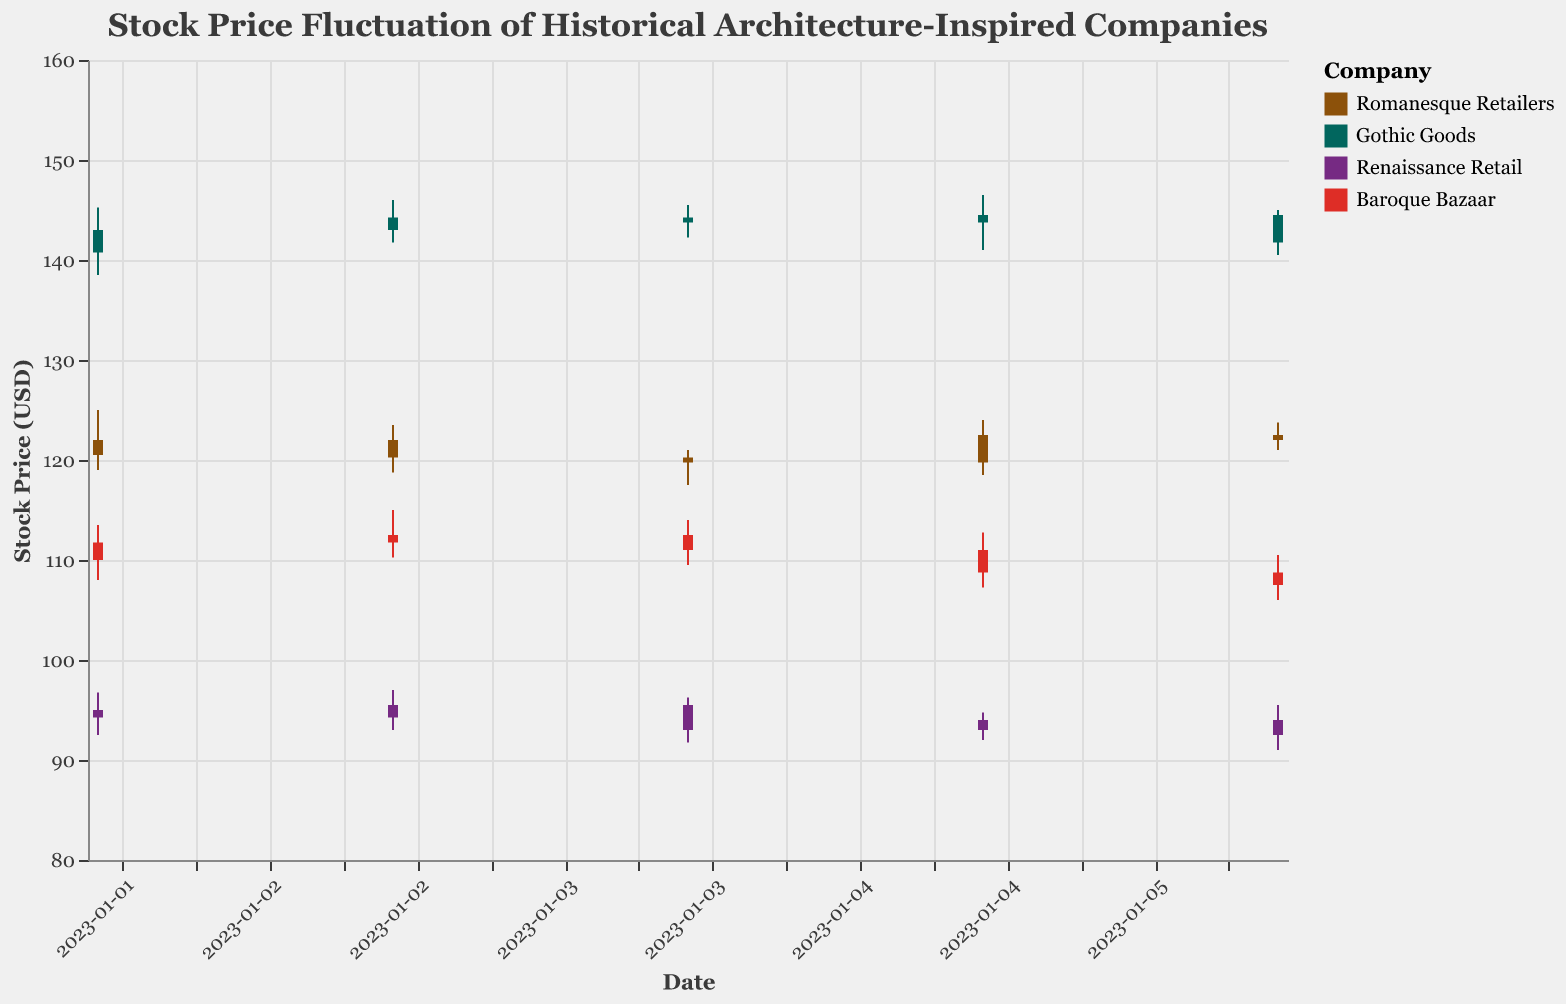What is the title of the figure? The title of the figure is displayed at the top. It reads "Stock Price Fluctuation of Historical Architecture-Inspired Companies".
Answer: Stock Price Fluctuation of Historical Architecture-Inspired Companies What colors represent the companies in the plot? The color legend at the right side of the plot shows different colors for each company: Romanesque Retailers is brown, Gothic Goods is green, Renaissance Retail is purple, and Baroque Bazaar is red.
Answer: Brown, Green, Purple, Red Which company had the highest stock price on 2023-01-02? On 2023-01-02, Gothic Goods had the highest stock price with a high value of 145.25.
Answer: Gothic Goods How did the stock price of Baroque Bazaar change from opening to closing on 2023-01-04? For Baroque Bazaar on 2023-01-04, the stock price opened at 112.50 and closed at 111.00, indicating a decrease in price.
Answer: Decreased Between which dates did Renaissance Retail experience the largest drop in its closing price? Comparing the closing prices, Renaissance Retail experienced the largest drop between 2023-01-05 (94.00) and 2023-01-06 (92.50), a decrease of 1.50.
Answer: 2023-01-05 and 2023-01-06 Which company’s stock price had the smallest range (difference between high and low) on any given day? On 2023-01-06, Gothic Goods had a high of 145.00 and a low of 140.50, with a range of 4.50. This is the smallest range for any company on any given day.
Answer: Gothic Goods What was the average closing price for Romanesque Retailers over the period shown? The closing prices for Romanesque Retailers are 122.00, 120.25, 119.75, 122.50, and 122.00. Summing these up (122.00 + 120.25 + 119.75 + 122.50 + 122.00) gives 606.50. Dividing by 5 (number of days), the average closing price is 121.30.
Answer: 121.30 Which day showed the highest volatility (difference between high and low) for any company's stock price? On 2023-01-03, Gothic Goods displayed the highest volatility with a high of 146.00 and a low of 141.75, resulting in a difference of 4.25.
Answer: 2023-01-03 For which dates did the Baroque Bazaar's opening price match its closing price? Examining the opening and closing prices, there is no date where Baroque Bazaar's opening price matches its closing price exactly.
Answer: None 